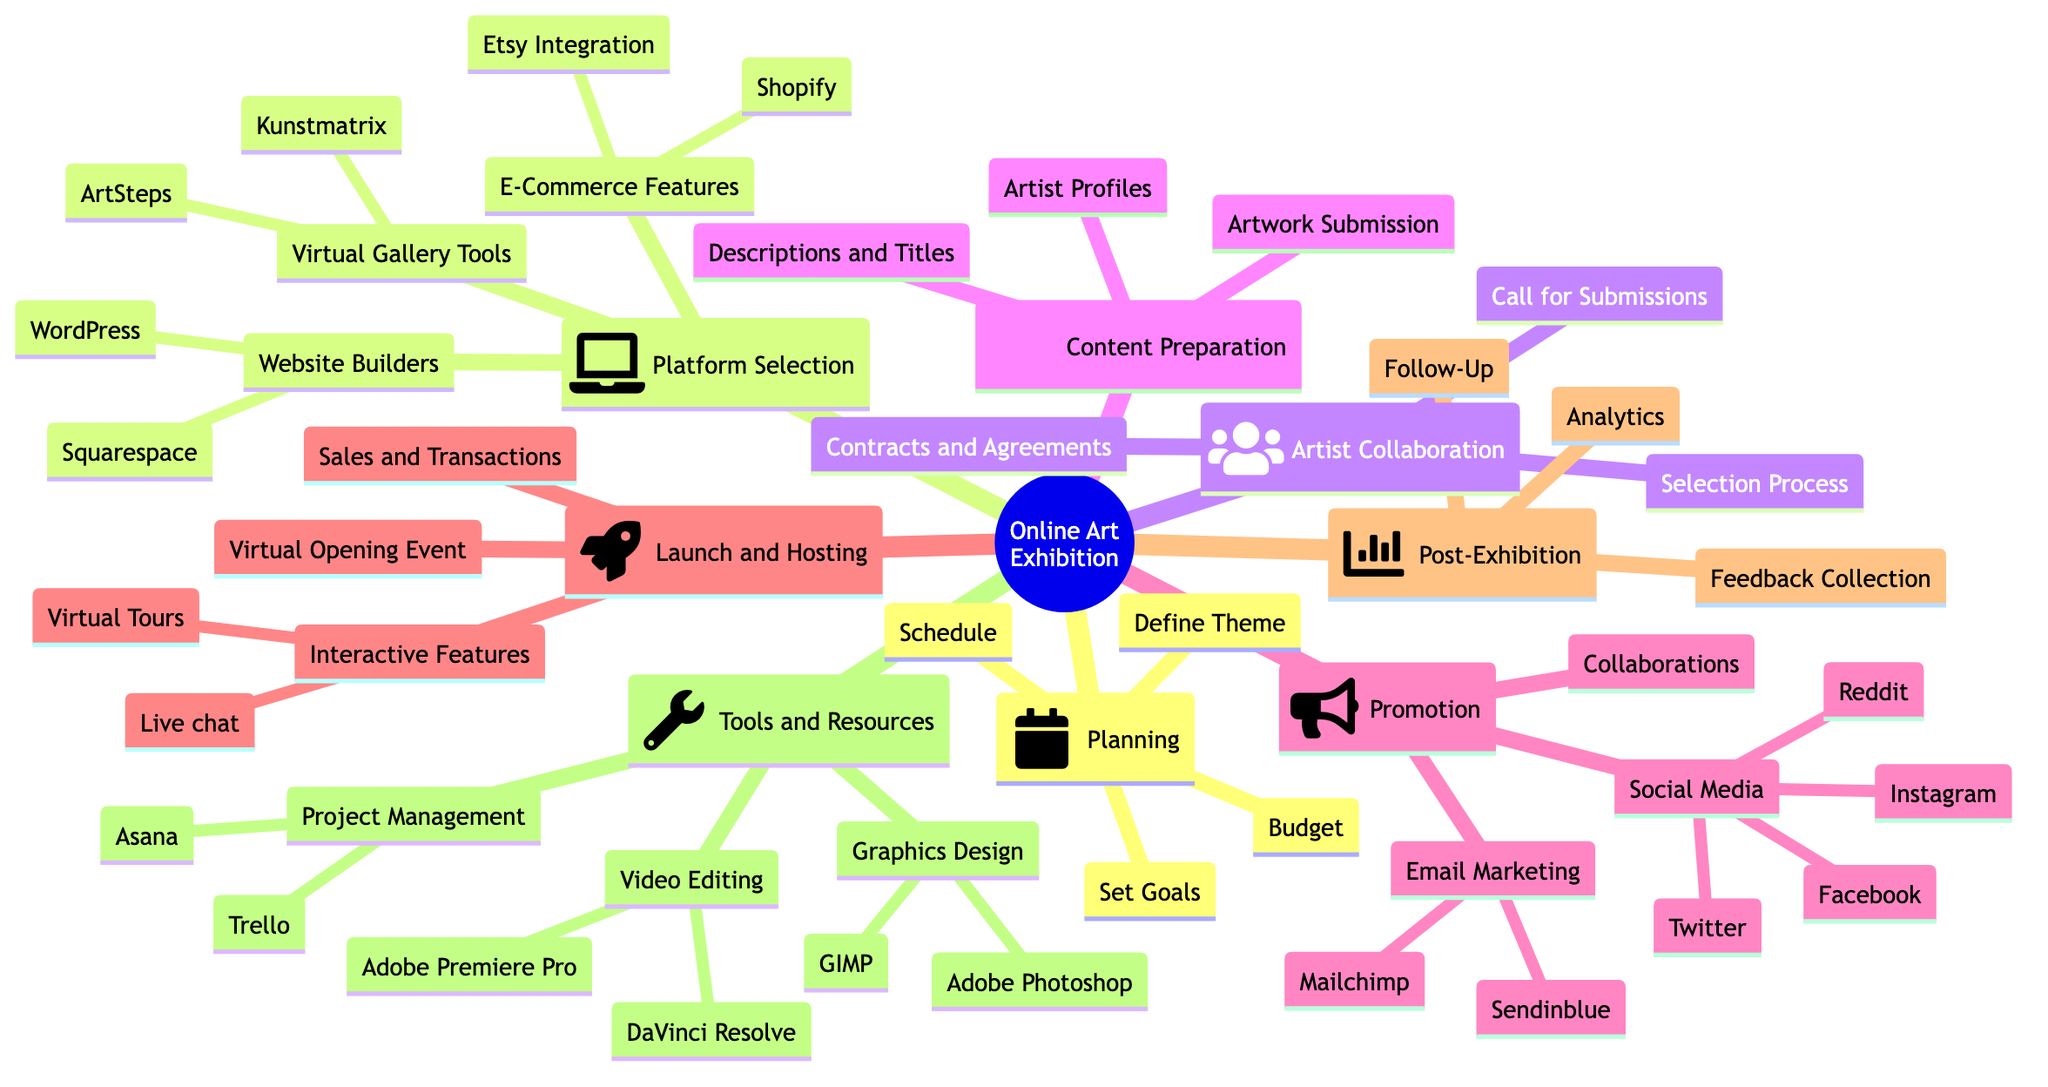What is the theme suggested for the exhibition? The theme is defined under "Define Theme" in the Planning section, which suggests selecting a cohesive theme such as "Digital Art and Anime".
Answer: Digital Art and Anime Which social media platforms are listed for promotion? The Promotion section includes a list of social media platforms: Twitter, Instagram, Facebook, and Reddit.
Answer: Twitter, Instagram, Facebook, Reddit How many main sections are there in the diagram? By counting the main branches, we can identify seven sections: Planning, Platform Selection, Artist Collaboration, Content Preparation, Promotion, Launch and Hosting, Post-Exhibition, and Tools and Resources.
Answer: 7 What tool is suggested for managing the project? Under the Tools and Resources section, "Trello" is listed as a project management tool.
Answer: Trello Where does "Virtual Tours" fall under in the diagram? "Virtual Tours" is found as a sub-node within the "Interactive Features" node, which is part of the "Launch and Hosting" section.
Answer: Launch and Hosting Which tools are available for Graphics Design? The Tools and Resources section lists "Adobe Photoshop" and "GIMP" under Graphics Design.
Answer: Adobe Photoshop, GIMP What is the purpose of the "Feedback Collection"? "Feedback Collection" is mentioned in the Post-Exhibition section as a means to gather feedback after the exhibition concludes.
Answer: Gather feedback How are artist contracts addressed in the diagram? The process regarding artist contracts is described in the "Contracts and Agreements" node under Artist Collaboration, indicating the use of standard artist contracts to ensure clarity on rights and payments.
Answer: Use standard artist contracts Which platform is suggested for Email Marketing? "Mailchimp" is highlighted in the Email Marketing sub-node under the Promotion section.
Answer: Mailchimp 